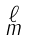Convert formula to latex. <formula><loc_0><loc_0><loc_500><loc_500>\begin{smallmatrix} \ell \\ m \end{smallmatrix}</formula> 